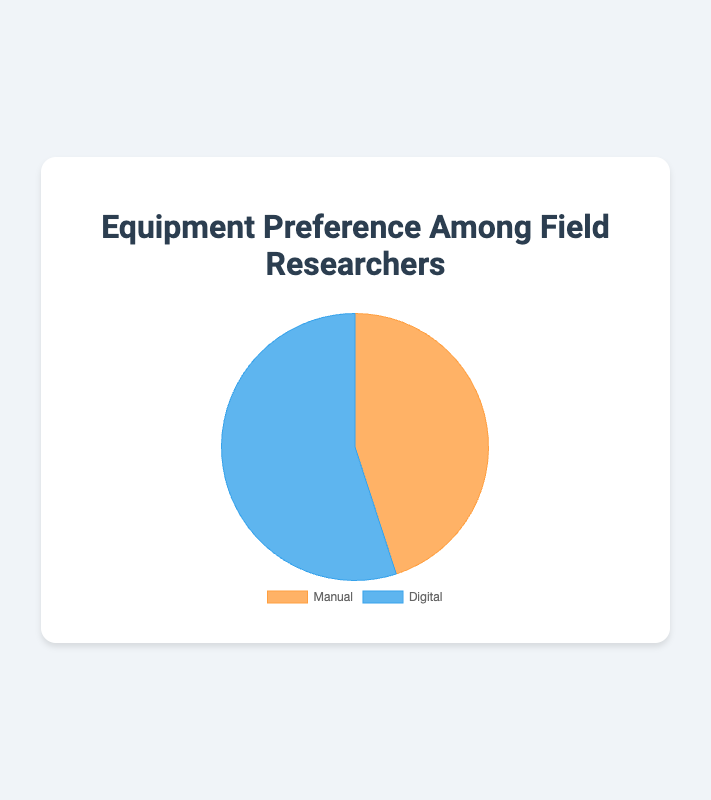what is the percentage preference for manual tools among field researchers? The pie chart shows that the portion labeled "Manual" represents 45% of the total preference.
Answer: 45% What is the percentage preference for digital tools among field researchers? The pie chart indicates that the segment labeled "Digital" makes up 55% of the total preference.
Answer: 55% Which type of tool is preferred more by field researchers, manual or digital? By comparing the segments on the pie chart, the "Digital" segment is larger with 55%, which is more than the 45% for the "Manual" segment.
Answer: Digital How much more percentage do digital tools have over manual tools? The preference percentage for digital tools is 55% and for manual tools is 45%. Subtracting these gives 55% - 45% = 10%.
Answer: 10% What is the ratio of preference between digital and manual tools? The preference for digital tools is 55% and for manual tools is 45%. The ratio is 55:45, which simplifies to 11:9.
Answer: 11:9 If you combine the percentages for manual and digital tools, what should the total be? Summing up the preference percentage for manual (45%) and digital (55%) should give 45% + 55% = 100%.
Answer: 100% Which tool type is represented by the blue color in the chart? The blue-color segment in the pie chart corresponds to the "Digital" tool type, as indicated by the legend.
Answer: Digital If 200 field researchers were surveyed, how many researchers prefer digital tools? Since 55% of the surveyed field researchers prefer digital tools, multiplying 200 by 0.55 gives 200 * 0.55 = 110 researchers.
Answer: 110 researchers If the preference for manual tools increased by 10 percentage points, what would be the new percentage preference for manual and digital tools? Increasing the preference for manual tools by 10 percentage points gives 45% + 10% = 55%. Consequently, the new preference for digital tools would be 100% - 55% = 45%.
Answer: Manual: 55%, Digital: 45% How would the pie chart visually change if digital tools had a preference of 70% instead of 55%? If digital tools were preferred by 70%, the segment for digital tools would take up a significantly larger portion of the pie chart, making the manual segment smaller, covering only 30% of the chart.
Answer: Digital segment larger, manual segment smaller 